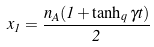<formula> <loc_0><loc_0><loc_500><loc_500>x _ { 1 } = \frac { n _ { A } ( 1 + \tanh _ { q } \gamma t ) } { 2 }</formula> 